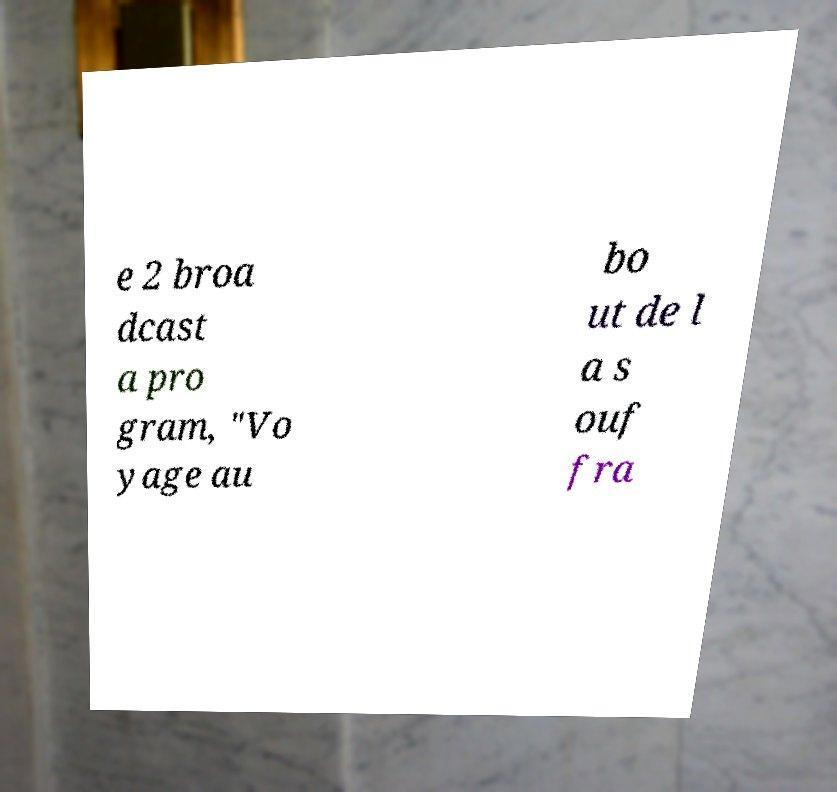Could you assist in decoding the text presented in this image and type it out clearly? e 2 broa dcast a pro gram, "Vo yage au bo ut de l a s ouf fra 